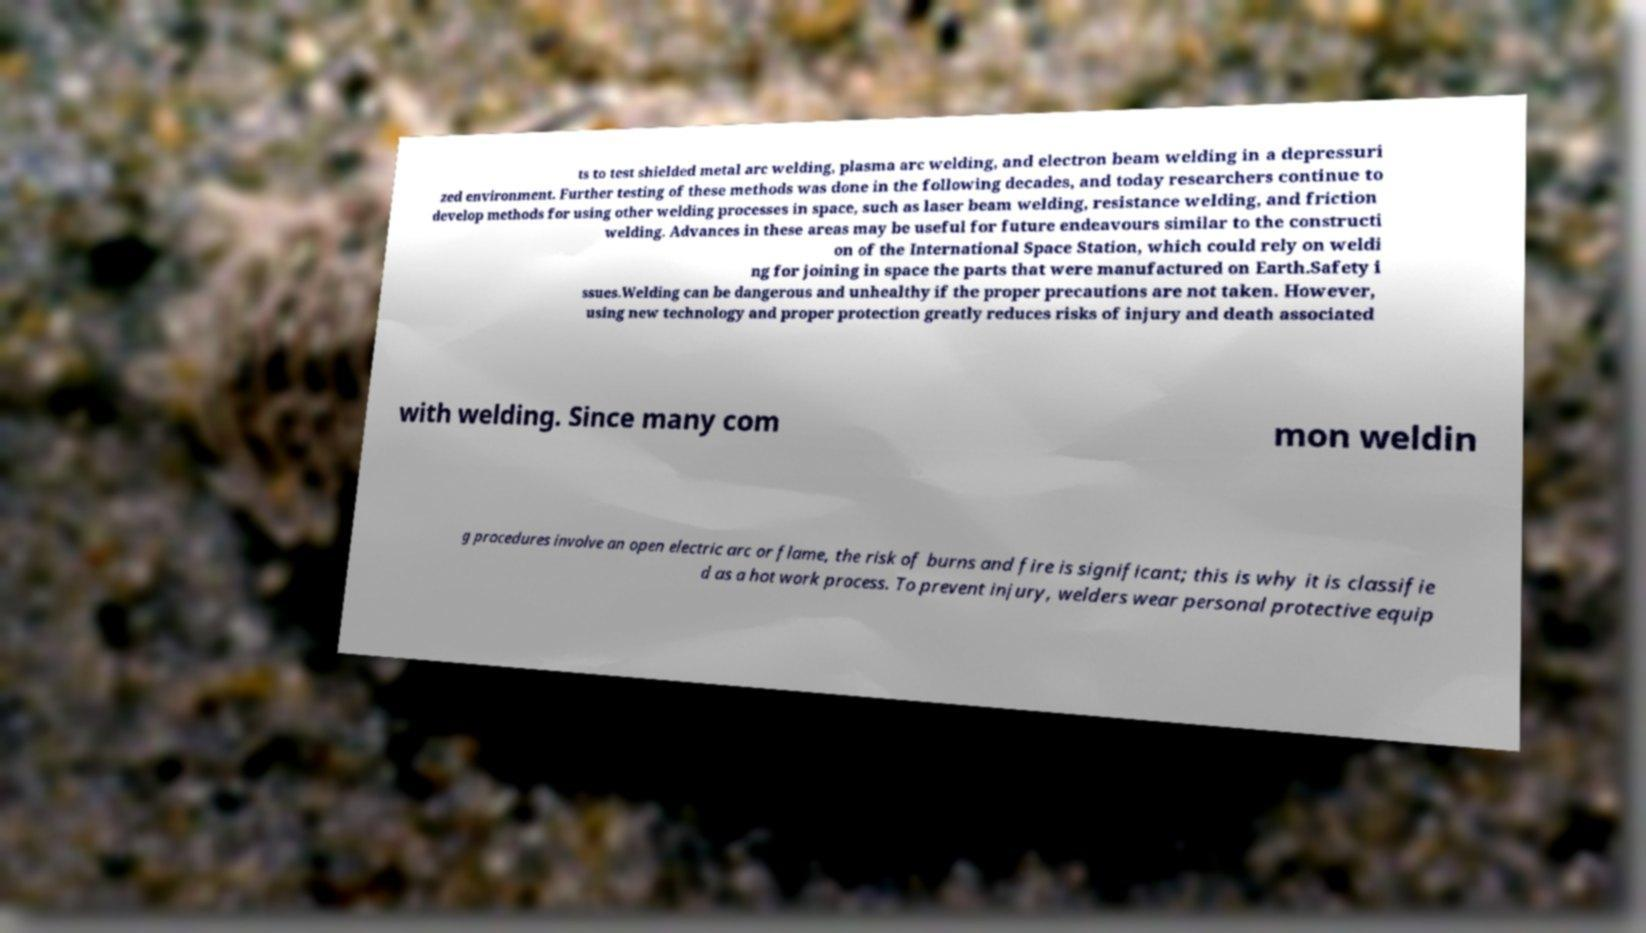I need the written content from this picture converted into text. Can you do that? ts to test shielded metal arc welding, plasma arc welding, and electron beam welding in a depressuri zed environment. Further testing of these methods was done in the following decades, and today researchers continue to develop methods for using other welding processes in space, such as laser beam welding, resistance welding, and friction welding. Advances in these areas may be useful for future endeavours similar to the constructi on of the International Space Station, which could rely on weldi ng for joining in space the parts that were manufactured on Earth.Safety i ssues.Welding can be dangerous and unhealthy if the proper precautions are not taken. However, using new technology and proper protection greatly reduces risks of injury and death associated with welding. Since many com mon weldin g procedures involve an open electric arc or flame, the risk of burns and fire is significant; this is why it is classifie d as a hot work process. To prevent injury, welders wear personal protective equip 